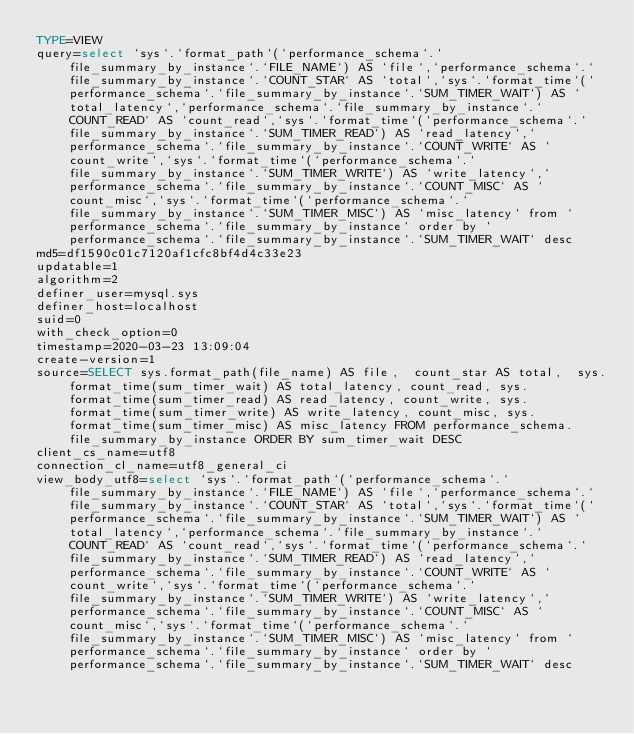<code> <loc_0><loc_0><loc_500><loc_500><_VisualBasic_>TYPE=VIEW
query=select `sys`.`format_path`(`performance_schema`.`file_summary_by_instance`.`FILE_NAME`) AS `file`,`performance_schema`.`file_summary_by_instance`.`COUNT_STAR` AS `total`,`sys`.`format_time`(`performance_schema`.`file_summary_by_instance`.`SUM_TIMER_WAIT`) AS `total_latency`,`performance_schema`.`file_summary_by_instance`.`COUNT_READ` AS `count_read`,`sys`.`format_time`(`performance_schema`.`file_summary_by_instance`.`SUM_TIMER_READ`) AS `read_latency`,`performance_schema`.`file_summary_by_instance`.`COUNT_WRITE` AS `count_write`,`sys`.`format_time`(`performance_schema`.`file_summary_by_instance`.`SUM_TIMER_WRITE`) AS `write_latency`,`performance_schema`.`file_summary_by_instance`.`COUNT_MISC` AS `count_misc`,`sys`.`format_time`(`performance_schema`.`file_summary_by_instance`.`SUM_TIMER_MISC`) AS `misc_latency` from `performance_schema`.`file_summary_by_instance` order by `performance_schema`.`file_summary_by_instance`.`SUM_TIMER_WAIT` desc
md5=df1590c01c7120af1cfc8bf4d4c33e23
updatable=1
algorithm=2
definer_user=mysql.sys
definer_host=localhost
suid=0
with_check_option=0
timestamp=2020-03-23 13:09:04
create-version=1
source=SELECT sys.format_path(file_name) AS file,  count_star AS total,  sys.format_time(sum_timer_wait) AS total_latency, count_read, sys.format_time(sum_timer_read) AS read_latency, count_write, sys.format_time(sum_timer_write) AS write_latency, count_misc, sys.format_time(sum_timer_misc) AS misc_latency FROM performance_schema.file_summary_by_instance ORDER BY sum_timer_wait DESC
client_cs_name=utf8
connection_cl_name=utf8_general_ci
view_body_utf8=select `sys`.`format_path`(`performance_schema`.`file_summary_by_instance`.`FILE_NAME`) AS `file`,`performance_schema`.`file_summary_by_instance`.`COUNT_STAR` AS `total`,`sys`.`format_time`(`performance_schema`.`file_summary_by_instance`.`SUM_TIMER_WAIT`) AS `total_latency`,`performance_schema`.`file_summary_by_instance`.`COUNT_READ` AS `count_read`,`sys`.`format_time`(`performance_schema`.`file_summary_by_instance`.`SUM_TIMER_READ`) AS `read_latency`,`performance_schema`.`file_summary_by_instance`.`COUNT_WRITE` AS `count_write`,`sys`.`format_time`(`performance_schema`.`file_summary_by_instance`.`SUM_TIMER_WRITE`) AS `write_latency`,`performance_schema`.`file_summary_by_instance`.`COUNT_MISC` AS `count_misc`,`sys`.`format_time`(`performance_schema`.`file_summary_by_instance`.`SUM_TIMER_MISC`) AS `misc_latency` from `performance_schema`.`file_summary_by_instance` order by `performance_schema`.`file_summary_by_instance`.`SUM_TIMER_WAIT` desc
</code> 